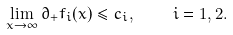<formula> <loc_0><loc_0><loc_500><loc_500>\lim _ { x \to \infty } \partial _ { + } f _ { i } ( x ) \leq c _ { i } , \quad i = 1 , 2 .</formula> 